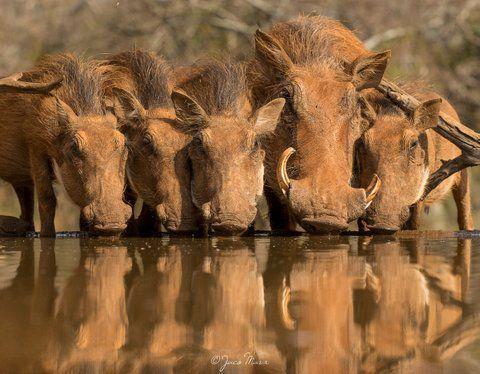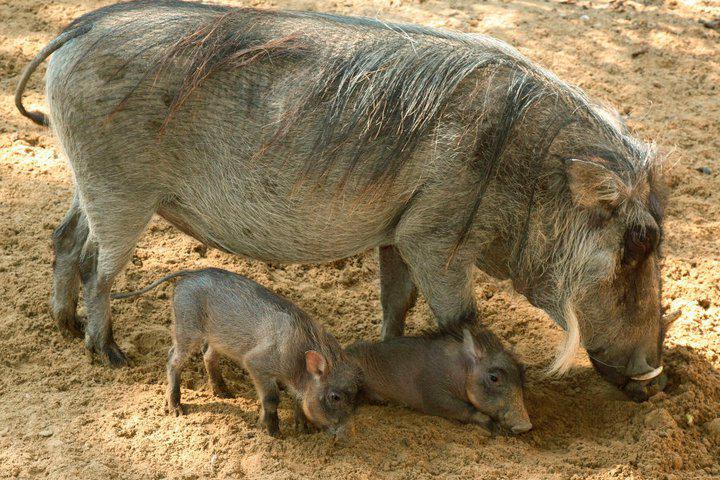The first image is the image on the left, the second image is the image on the right. Assess this claim about the two images: "In one image there are at least two warthogs drinking out of a pond.". Correct or not? Answer yes or no. Yes. The first image is the image on the left, the second image is the image on the right. Considering the images on both sides, is "the left image has at most 2 wartgogs" valid? Answer yes or no. No. 